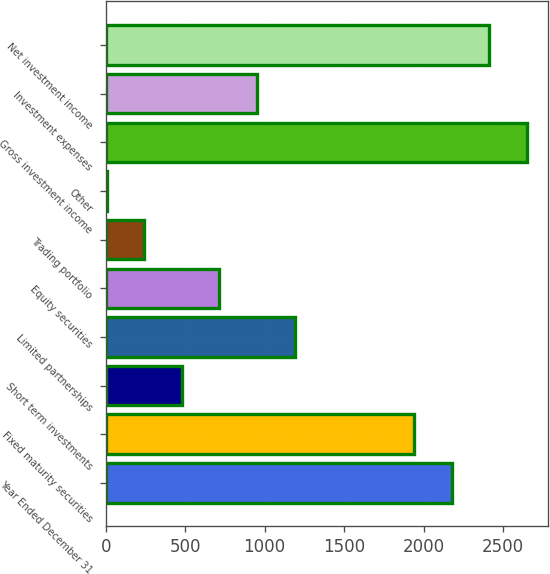Convert chart. <chart><loc_0><loc_0><loc_500><loc_500><bar_chart><fcel>Year Ended December 31<fcel>Fixed maturity securities<fcel>Short term investments<fcel>Limited partnerships<fcel>Equity securities<fcel>Trading portfolio<fcel>Other<fcel>Gross investment income<fcel>Investment expenses<fcel>Net investment income<nl><fcel>2177.4<fcel>1941<fcel>478.8<fcel>1188<fcel>715.2<fcel>242.4<fcel>6<fcel>2650.2<fcel>951.6<fcel>2413.8<nl></chart> 